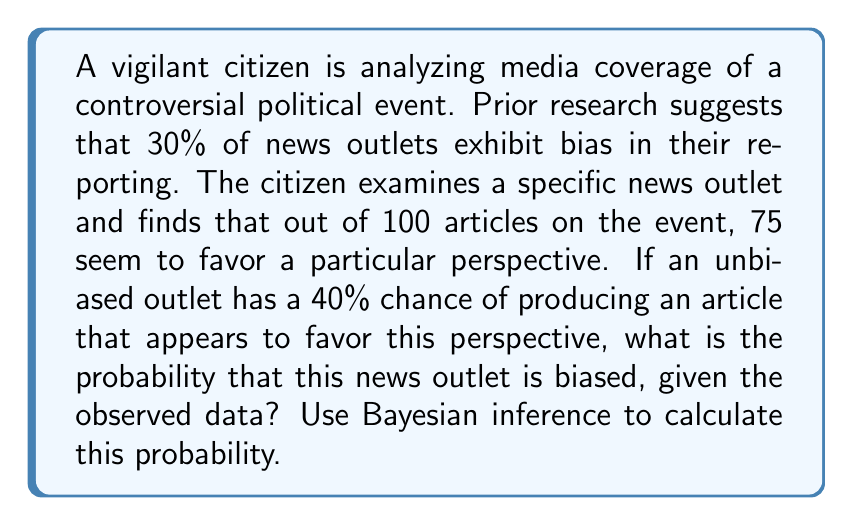Can you answer this question? To solve this problem, we'll use Bayes' theorem:

$$P(B|D) = \frac{P(D|B) \cdot P(B)}{P(D)}$$

Where:
$B$ = the event that the news outlet is biased
$D$ = the observed data (75 out of 100 articles favoring a particular perspective)

Step 1: Define the prior probability
$P(B) = 0.30$ (30% of news outlets are biased)

Step 2: Calculate the likelihood
For a biased outlet, we assume all articles favor the perspective:
$P(D|B) = \binom{100}{75} \cdot 1^{75} \cdot 0^{25} = 1$

For an unbiased outlet:
$P(D|\text{not }B) = \binom{100}{75} \cdot 0.4^{75} \cdot 0.6^{25}$

Step 3: Calculate the marginal likelihood
$$P(D) = P(D|B) \cdot P(B) + P(D|\text{not }B) \cdot P(\text{not }B)$$
$$P(D) = 1 \cdot 0.30 + \binom{100}{75} \cdot 0.4^{75} \cdot 0.6^{25} \cdot 0.70$$

Step 4: Apply Bayes' theorem
$$P(B|D) = \frac{1 \cdot 0.30}{0.30 + \binom{100}{75} \cdot 0.4^{75} \cdot 0.6^{25} \cdot 0.70}$$

Step 5: Calculate the final probability
Using a calculator or computer, we can evaluate this expression.
Answer: $P(B|D) \approx 0.9999$ (99.99%) 